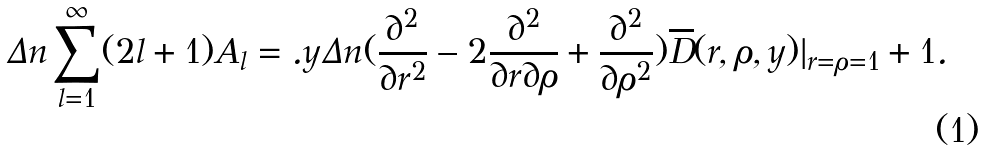<formula> <loc_0><loc_0><loc_500><loc_500>\Delta n \sum _ { l = 1 } ^ { \infty } ( 2 l + 1 ) A _ { l } = . y \Delta n ( \frac { \partial ^ { 2 } } { \partial r ^ { 2 } } - 2 \frac { \partial ^ { 2 } } { \partial r \partial \rho } + \frac { \partial ^ { 2 } } { \partial \rho ^ { 2 } } ) \overline { D } ( r , \rho , y ) | _ { r = \rho = 1 } + 1 .</formula> 